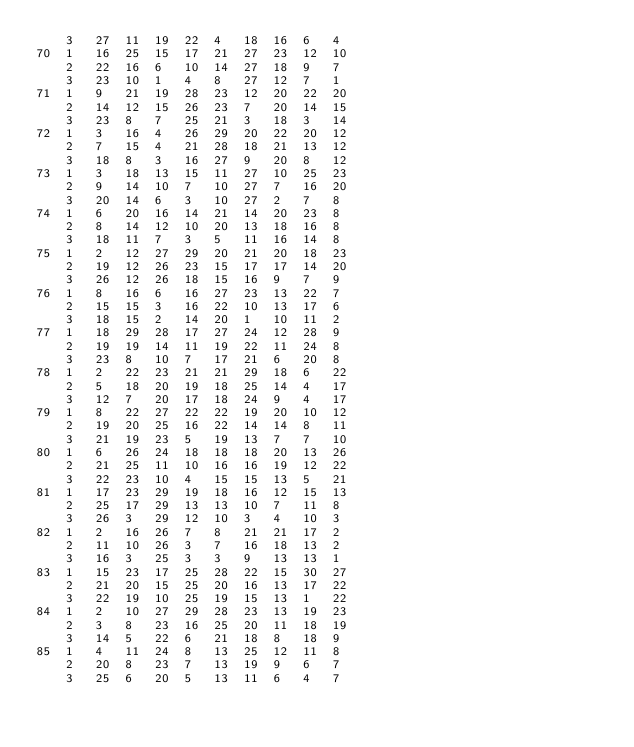Convert code to text. <code><loc_0><loc_0><loc_500><loc_500><_ObjectiveC_>	3	27	11	19	22	4	18	16	6	4	
70	1	16	25	15	17	21	27	23	12	10	
	2	22	16	6	10	14	27	18	9	7	
	3	23	10	1	4	8	27	12	7	1	
71	1	9	21	19	28	23	12	20	22	20	
	2	14	12	15	26	23	7	20	14	15	
	3	23	8	7	25	21	3	18	3	14	
72	1	3	16	4	26	29	20	22	20	12	
	2	7	15	4	21	28	18	21	13	12	
	3	18	8	3	16	27	9	20	8	12	
73	1	3	18	13	15	11	27	10	25	23	
	2	9	14	10	7	10	27	7	16	20	
	3	20	14	6	3	10	27	2	7	8	
74	1	6	20	16	14	21	14	20	23	8	
	2	8	14	12	10	20	13	18	16	8	
	3	18	11	7	3	5	11	16	14	8	
75	1	2	12	27	29	20	21	20	18	23	
	2	19	12	26	23	15	17	17	14	20	
	3	26	12	26	18	15	16	9	7	9	
76	1	8	16	6	16	27	23	13	22	7	
	2	15	15	3	16	22	10	13	17	6	
	3	18	15	2	14	20	1	10	11	2	
77	1	18	29	28	17	27	24	12	28	9	
	2	19	19	14	11	19	22	11	24	8	
	3	23	8	10	7	17	21	6	20	8	
78	1	2	22	23	21	21	29	18	6	22	
	2	5	18	20	19	18	25	14	4	17	
	3	12	7	20	17	18	24	9	4	17	
79	1	8	22	27	22	22	19	20	10	12	
	2	19	20	25	16	22	14	14	8	11	
	3	21	19	23	5	19	13	7	7	10	
80	1	6	26	24	18	18	18	20	13	26	
	2	21	25	11	10	16	16	19	12	22	
	3	22	23	10	4	15	15	13	5	21	
81	1	17	23	29	19	18	16	12	15	13	
	2	25	17	29	13	13	10	7	11	8	
	3	26	3	29	12	10	3	4	10	3	
82	1	2	16	26	7	8	21	21	17	2	
	2	11	10	26	3	7	16	18	13	2	
	3	16	3	25	3	3	9	13	13	1	
83	1	15	23	17	25	28	22	15	30	27	
	2	21	20	15	25	20	16	13	17	22	
	3	22	19	10	25	19	15	13	1	22	
84	1	2	10	27	29	28	23	13	19	23	
	2	3	8	23	16	25	20	11	18	19	
	3	14	5	22	6	21	18	8	18	9	
85	1	4	11	24	8	13	25	12	11	8	
	2	20	8	23	7	13	19	9	6	7	
	3	25	6	20	5	13	11	6	4	7	</code> 